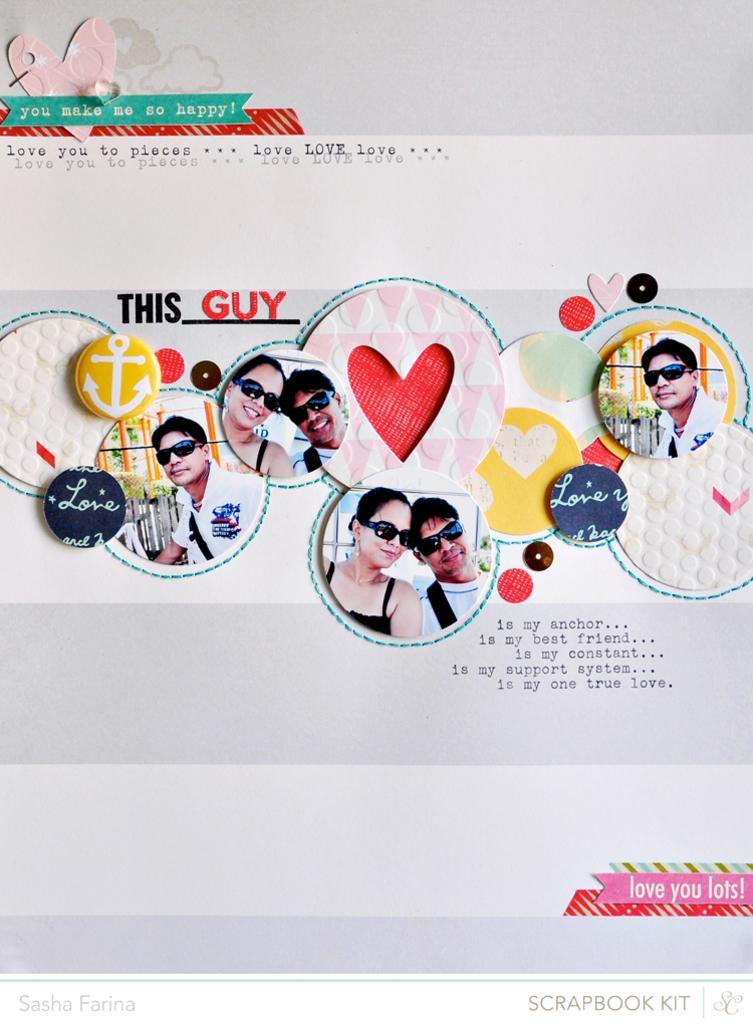Could you give a brief overview of what you see in this image? In the center of the image we can see one poster. On the poster, we can see a few people are wearing sunglasses. Among them, we can see a few people are smiling. And we can see the design on the poster. On the poster, we can see some text. 